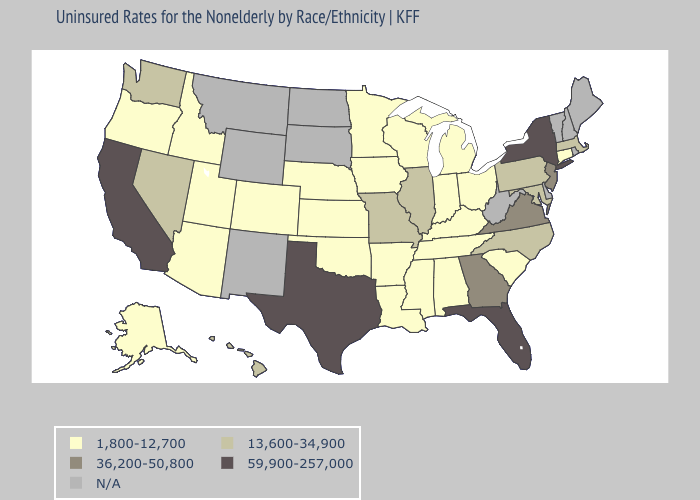Which states hav the highest value in the South?
Short answer required. Florida, Texas. What is the value of Missouri?
Be succinct. 13,600-34,900. What is the value of Florida?
Concise answer only. 59,900-257,000. What is the lowest value in the Northeast?
Keep it brief. 1,800-12,700. What is the lowest value in the South?
Concise answer only. 1,800-12,700. Does the first symbol in the legend represent the smallest category?
Be succinct. Yes. What is the highest value in the USA?
Concise answer only. 59,900-257,000. Does Connecticut have the lowest value in the Northeast?
Answer briefly. Yes. Name the states that have a value in the range 13,600-34,900?
Keep it brief. Hawaii, Illinois, Maryland, Massachusetts, Missouri, Nevada, North Carolina, Pennsylvania, Washington. What is the value of Michigan?
Write a very short answer. 1,800-12,700. Name the states that have a value in the range N/A?
Write a very short answer. Delaware, Maine, Montana, New Hampshire, New Mexico, North Dakota, Rhode Island, South Dakota, Vermont, West Virginia, Wyoming. 